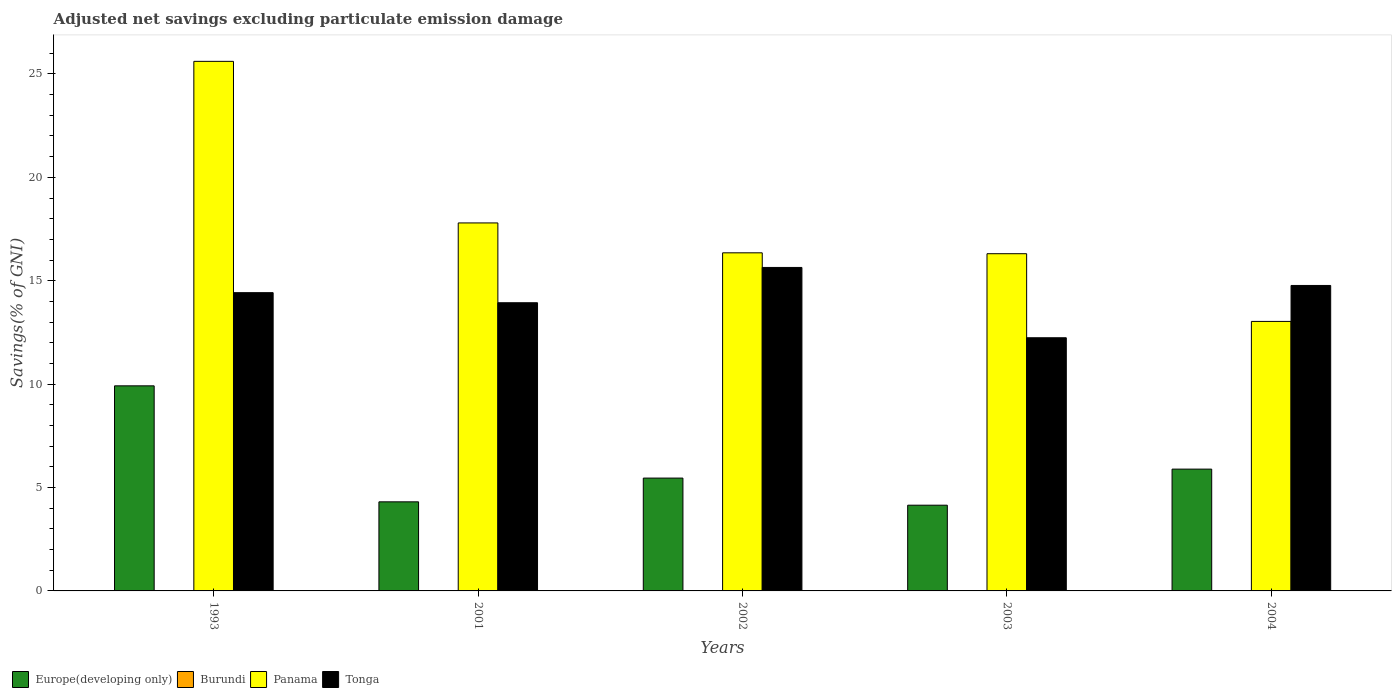How many different coloured bars are there?
Make the answer very short. 3. How many groups of bars are there?
Provide a short and direct response. 5. Are the number of bars on each tick of the X-axis equal?
Your answer should be very brief. Yes. How many bars are there on the 1st tick from the left?
Your response must be concise. 3. What is the label of the 4th group of bars from the left?
Make the answer very short. 2003. What is the adjusted net savings in Burundi in 2004?
Your answer should be compact. 0. Across all years, what is the maximum adjusted net savings in Panama?
Provide a short and direct response. 25.61. Across all years, what is the minimum adjusted net savings in Panama?
Your answer should be compact. 13.03. What is the total adjusted net savings in Europe(developing only) in the graph?
Your answer should be compact. 29.72. What is the difference between the adjusted net savings in Panama in 2001 and that in 2004?
Your response must be concise. 4.76. What is the difference between the adjusted net savings in Europe(developing only) in 1993 and the adjusted net savings in Panama in 2004?
Keep it short and to the point. -3.12. What is the average adjusted net savings in Burundi per year?
Offer a terse response. 0. In the year 1993, what is the difference between the adjusted net savings in Panama and adjusted net savings in Europe(developing only)?
Make the answer very short. 15.69. In how many years, is the adjusted net savings in Europe(developing only) greater than 20 %?
Your answer should be compact. 0. What is the ratio of the adjusted net savings in Panama in 2001 to that in 2004?
Provide a short and direct response. 1.37. What is the difference between the highest and the second highest adjusted net savings in Europe(developing only)?
Your answer should be compact. 4.03. What is the difference between the highest and the lowest adjusted net savings in Panama?
Give a very brief answer. 12.58. Is the sum of the adjusted net savings in Tonga in 1993 and 2003 greater than the maximum adjusted net savings in Panama across all years?
Ensure brevity in your answer.  Yes. Is it the case that in every year, the sum of the adjusted net savings in Burundi and adjusted net savings in Tonga is greater than the sum of adjusted net savings in Panama and adjusted net savings in Europe(developing only)?
Ensure brevity in your answer.  No. Is it the case that in every year, the sum of the adjusted net savings in Tonga and adjusted net savings in Burundi is greater than the adjusted net savings in Panama?
Ensure brevity in your answer.  No. How many bars are there?
Give a very brief answer. 15. How many years are there in the graph?
Provide a succinct answer. 5. What is the difference between two consecutive major ticks on the Y-axis?
Provide a succinct answer. 5. Are the values on the major ticks of Y-axis written in scientific E-notation?
Provide a succinct answer. No. Where does the legend appear in the graph?
Your answer should be very brief. Bottom left. How are the legend labels stacked?
Offer a very short reply. Horizontal. What is the title of the graph?
Ensure brevity in your answer.  Adjusted net savings excluding particulate emission damage. Does "Mauritania" appear as one of the legend labels in the graph?
Offer a terse response. No. What is the label or title of the Y-axis?
Provide a succinct answer. Savings(% of GNI). What is the Savings(% of GNI) of Europe(developing only) in 1993?
Offer a very short reply. 9.92. What is the Savings(% of GNI) in Burundi in 1993?
Your response must be concise. 0. What is the Savings(% of GNI) of Panama in 1993?
Provide a succinct answer. 25.61. What is the Savings(% of GNI) of Tonga in 1993?
Keep it short and to the point. 14.42. What is the Savings(% of GNI) of Europe(developing only) in 2001?
Offer a very short reply. 4.31. What is the Savings(% of GNI) in Panama in 2001?
Your answer should be compact. 17.8. What is the Savings(% of GNI) in Tonga in 2001?
Your response must be concise. 13.94. What is the Savings(% of GNI) of Europe(developing only) in 2002?
Give a very brief answer. 5.46. What is the Savings(% of GNI) of Burundi in 2002?
Provide a succinct answer. 0. What is the Savings(% of GNI) in Panama in 2002?
Offer a very short reply. 16.35. What is the Savings(% of GNI) of Tonga in 2002?
Provide a succinct answer. 15.64. What is the Savings(% of GNI) of Europe(developing only) in 2003?
Make the answer very short. 4.15. What is the Savings(% of GNI) of Burundi in 2003?
Your answer should be very brief. 0. What is the Savings(% of GNI) of Panama in 2003?
Provide a succinct answer. 16.31. What is the Savings(% of GNI) in Tonga in 2003?
Offer a terse response. 12.24. What is the Savings(% of GNI) in Europe(developing only) in 2004?
Offer a terse response. 5.89. What is the Savings(% of GNI) of Panama in 2004?
Keep it short and to the point. 13.03. What is the Savings(% of GNI) in Tonga in 2004?
Your answer should be compact. 14.77. Across all years, what is the maximum Savings(% of GNI) in Europe(developing only)?
Your answer should be very brief. 9.92. Across all years, what is the maximum Savings(% of GNI) in Panama?
Make the answer very short. 25.61. Across all years, what is the maximum Savings(% of GNI) in Tonga?
Give a very brief answer. 15.64. Across all years, what is the minimum Savings(% of GNI) in Europe(developing only)?
Give a very brief answer. 4.15. Across all years, what is the minimum Savings(% of GNI) of Panama?
Provide a succinct answer. 13.03. Across all years, what is the minimum Savings(% of GNI) of Tonga?
Give a very brief answer. 12.24. What is the total Savings(% of GNI) in Europe(developing only) in the graph?
Your answer should be very brief. 29.72. What is the total Savings(% of GNI) of Burundi in the graph?
Your response must be concise. 0. What is the total Savings(% of GNI) of Panama in the graph?
Your answer should be compact. 89.1. What is the total Savings(% of GNI) of Tonga in the graph?
Your response must be concise. 71.02. What is the difference between the Savings(% of GNI) in Europe(developing only) in 1993 and that in 2001?
Your response must be concise. 5.61. What is the difference between the Savings(% of GNI) in Panama in 1993 and that in 2001?
Make the answer very short. 7.81. What is the difference between the Savings(% of GNI) in Tonga in 1993 and that in 2001?
Your answer should be very brief. 0.49. What is the difference between the Savings(% of GNI) of Europe(developing only) in 1993 and that in 2002?
Provide a succinct answer. 4.46. What is the difference between the Savings(% of GNI) in Panama in 1993 and that in 2002?
Offer a very short reply. 9.26. What is the difference between the Savings(% of GNI) of Tonga in 1993 and that in 2002?
Ensure brevity in your answer.  -1.22. What is the difference between the Savings(% of GNI) in Europe(developing only) in 1993 and that in 2003?
Provide a short and direct response. 5.77. What is the difference between the Savings(% of GNI) of Panama in 1993 and that in 2003?
Keep it short and to the point. 9.3. What is the difference between the Savings(% of GNI) in Tonga in 1993 and that in 2003?
Your answer should be compact. 2.18. What is the difference between the Savings(% of GNI) in Europe(developing only) in 1993 and that in 2004?
Your response must be concise. 4.03. What is the difference between the Savings(% of GNI) in Panama in 1993 and that in 2004?
Give a very brief answer. 12.58. What is the difference between the Savings(% of GNI) in Tonga in 1993 and that in 2004?
Keep it short and to the point. -0.35. What is the difference between the Savings(% of GNI) of Europe(developing only) in 2001 and that in 2002?
Give a very brief answer. -1.15. What is the difference between the Savings(% of GNI) in Panama in 2001 and that in 2002?
Your answer should be compact. 1.45. What is the difference between the Savings(% of GNI) in Tonga in 2001 and that in 2002?
Ensure brevity in your answer.  -1.71. What is the difference between the Savings(% of GNI) of Europe(developing only) in 2001 and that in 2003?
Provide a succinct answer. 0.16. What is the difference between the Savings(% of GNI) in Panama in 2001 and that in 2003?
Your answer should be compact. 1.49. What is the difference between the Savings(% of GNI) of Tonga in 2001 and that in 2003?
Provide a short and direct response. 1.69. What is the difference between the Savings(% of GNI) in Europe(developing only) in 2001 and that in 2004?
Keep it short and to the point. -1.58. What is the difference between the Savings(% of GNI) of Panama in 2001 and that in 2004?
Offer a very short reply. 4.76. What is the difference between the Savings(% of GNI) of Tonga in 2001 and that in 2004?
Your answer should be compact. -0.84. What is the difference between the Savings(% of GNI) of Europe(developing only) in 2002 and that in 2003?
Your answer should be compact. 1.31. What is the difference between the Savings(% of GNI) in Panama in 2002 and that in 2003?
Offer a terse response. 0.04. What is the difference between the Savings(% of GNI) in Tonga in 2002 and that in 2003?
Keep it short and to the point. 3.4. What is the difference between the Savings(% of GNI) of Europe(developing only) in 2002 and that in 2004?
Provide a short and direct response. -0.43. What is the difference between the Savings(% of GNI) of Panama in 2002 and that in 2004?
Provide a succinct answer. 3.32. What is the difference between the Savings(% of GNI) of Tonga in 2002 and that in 2004?
Offer a very short reply. 0.87. What is the difference between the Savings(% of GNI) of Europe(developing only) in 2003 and that in 2004?
Keep it short and to the point. -1.74. What is the difference between the Savings(% of GNI) of Panama in 2003 and that in 2004?
Offer a very short reply. 3.27. What is the difference between the Savings(% of GNI) in Tonga in 2003 and that in 2004?
Offer a terse response. -2.53. What is the difference between the Savings(% of GNI) in Europe(developing only) in 1993 and the Savings(% of GNI) in Panama in 2001?
Offer a terse response. -7.88. What is the difference between the Savings(% of GNI) in Europe(developing only) in 1993 and the Savings(% of GNI) in Tonga in 2001?
Your answer should be very brief. -4.02. What is the difference between the Savings(% of GNI) of Panama in 1993 and the Savings(% of GNI) of Tonga in 2001?
Your response must be concise. 11.67. What is the difference between the Savings(% of GNI) in Europe(developing only) in 1993 and the Savings(% of GNI) in Panama in 2002?
Your response must be concise. -6.43. What is the difference between the Savings(% of GNI) in Europe(developing only) in 1993 and the Savings(% of GNI) in Tonga in 2002?
Offer a very short reply. -5.73. What is the difference between the Savings(% of GNI) of Panama in 1993 and the Savings(% of GNI) of Tonga in 2002?
Your response must be concise. 9.97. What is the difference between the Savings(% of GNI) in Europe(developing only) in 1993 and the Savings(% of GNI) in Panama in 2003?
Keep it short and to the point. -6.39. What is the difference between the Savings(% of GNI) in Europe(developing only) in 1993 and the Savings(% of GNI) in Tonga in 2003?
Give a very brief answer. -2.33. What is the difference between the Savings(% of GNI) of Panama in 1993 and the Savings(% of GNI) of Tonga in 2003?
Keep it short and to the point. 13.37. What is the difference between the Savings(% of GNI) in Europe(developing only) in 1993 and the Savings(% of GNI) in Panama in 2004?
Your answer should be compact. -3.12. What is the difference between the Savings(% of GNI) in Europe(developing only) in 1993 and the Savings(% of GNI) in Tonga in 2004?
Make the answer very short. -4.85. What is the difference between the Savings(% of GNI) of Panama in 1993 and the Savings(% of GNI) of Tonga in 2004?
Your answer should be very brief. 10.84. What is the difference between the Savings(% of GNI) in Europe(developing only) in 2001 and the Savings(% of GNI) in Panama in 2002?
Offer a very short reply. -12.04. What is the difference between the Savings(% of GNI) in Europe(developing only) in 2001 and the Savings(% of GNI) in Tonga in 2002?
Provide a succinct answer. -11.34. What is the difference between the Savings(% of GNI) in Panama in 2001 and the Savings(% of GNI) in Tonga in 2002?
Your answer should be compact. 2.15. What is the difference between the Savings(% of GNI) in Europe(developing only) in 2001 and the Savings(% of GNI) in Panama in 2003?
Give a very brief answer. -12. What is the difference between the Savings(% of GNI) in Europe(developing only) in 2001 and the Savings(% of GNI) in Tonga in 2003?
Your answer should be very brief. -7.93. What is the difference between the Savings(% of GNI) of Panama in 2001 and the Savings(% of GNI) of Tonga in 2003?
Provide a short and direct response. 5.55. What is the difference between the Savings(% of GNI) in Europe(developing only) in 2001 and the Savings(% of GNI) in Panama in 2004?
Give a very brief answer. -8.72. What is the difference between the Savings(% of GNI) in Europe(developing only) in 2001 and the Savings(% of GNI) in Tonga in 2004?
Ensure brevity in your answer.  -10.46. What is the difference between the Savings(% of GNI) of Panama in 2001 and the Savings(% of GNI) of Tonga in 2004?
Your answer should be very brief. 3.02. What is the difference between the Savings(% of GNI) in Europe(developing only) in 2002 and the Savings(% of GNI) in Panama in 2003?
Offer a terse response. -10.85. What is the difference between the Savings(% of GNI) in Europe(developing only) in 2002 and the Savings(% of GNI) in Tonga in 2003?
Offer a terse response. -6.79. What is the difference between the Savings(% of GNI) of Panama in 2002 and the Savings(% of GNI) of Tonga in 2003?
Your answer should be very brief. 4.11. What is the difference between the Savings(% of GNI) in Europe(developing only) in 2002 and the Savings(% of GNI) in Panama in 2004?
Your response must be concise. -7.58. What is the difference between the Savings(% of GNI) in Europe(developing only) in 2002 and the Savings(% of GNI) in Tonga in 2004?
Ensure brevity in your answer.  -9.31. What is the difference between the Savings(% of GNI) in Panama in 2002 and the Savings(% of GNI) in Tonga in 2004?
Ensure brevity in your answer.  1.58. What is the difference between the Savings(% of GNI) of Europe(developing only) in 2003 and the Savings(% of GNI) of Panama in 2004?
Offer a very short reply. -8.89. What is the difference between the Savings(% of GNI) in Europe(developing only) in 2003 and the Savings(% of GNI) in Tonga in 2004?
Give a very brief answer. -10.63. What is the difference between the Savings(% of GNI) of Panama in 2003 and the Savings(% of GNI) of Tonga in 2004?
Make the answer very short. 1.54. What is the average Savings(% of GNI) of Europe(developing only) per year?
Make the answer very short. 5.94. What is the average Savings(% of GNI) in Burundi per year?
Offer a terse response. 0. What is the average Savings(% of GNI) of Panama per year?
Provide a short and direct response. 17.82. What is the average Savings(% of GNI) of Tonga per year?
Give a very brief answer. 14.2. In the year 1993, what is the difference between the Savings(% of GNI) in Europe(developing only) and Savings(% of GNI) in Panama?
Your response must be concise. -15.69. In the year 1993, what is the difference between the Savings(% of GNI) in Europe(developing only) and Savings(% of GNI) in Tonga?
Offer a very short reply. -4.51. In the year 1993, what is the difference between the Savings(% of GNI) of Panama and Savings(% of GNI) of Tonga?
Offer a terse response. 11.19. In the year 2001, what is the difference between the Savings(% of GNI) of Europe(developing only) and Savings(% of GNI) of Panama?
Provide a succinct answer. -13.49. In the year 2001, what is the difference between the Savings(% of GNI) of Europe(developing only) and Savings(% of GNI) of Tonga?
Your answer should be very brief. -9.63. In the year 2001, what is the difference between the Savings(% of GNI) of Panama and Savings(% of GNI) of Tonga?
Your response must be concise. 3.86. In the year 2002, what is the difference between the Savings(% of GNI) in Europe(developing only) and Savings(% of GNI) in Panama?
Keep it short and to the point. -10.89. In the year 2002, what is the difference between the Savings(% of GNI) in Europe(developing only) and Savings(% of GNI) in Tonga?
Your response must be concise. -10.19. In the year 2002, what is the difference between the Savings(% of GNI) in Panama and Savings(% of GNI) in Tonga?
Provide a succinct answer. 0.71. In the year 2003, what is the difference between the Savings(% of GNI) in Europe(developing only) and Savings(% of GNI) in Panama?
Your answer should be very brief. -12.16. In the year 2003, what is the difference between the Savings(% of GNI) of Europe(developing only) and Savings(% of GNI) of Tonga?
Your answer should be compact. -8.1. In the year 2003, what is the difference between the Savings(% of GNI) of Panama and Savings(% of GNI) of Tonga?
Your answer should be very brief. 4.06. In the year 2004, what is the difference between the Savings(% of GNI) of Europe(developing only) and Savings(% of GNI) of Panama?
Your answer should be very brief. -7.14. In the year 2004, what is the difference between the Savings(% of GNI) of Europe(developing only) and Savings(% of GNI) of Tonga?
Keep it short and to the point. -8.88. In the year 2004, what is the difference between the Savings(% of GNI) of Panama and Savings(% of GNI) of Tonga?
Keep it short and to the point. -1.74. What is the ratio of the Savings(% of GNI) of Europe(developing only) in 1993 to that in 2001?
Your answer should be compact. 2.3. What is the ratio of the Savings(% of GNI) in Panama in 1993 to that in 2001?
Ensure brevity in your answer.  1.44. What is the ratio of the Savings(% of GNI) in Tonga in 1993 to that in 2001?
Keep it short and to the point. 1.03. What is the ratio of the Savings(% of GNI) of Europe(developing only) in 1993 to that in 2002?
Keep it short and to the point. 1.82. What is the ratio of the Savings(% of GNI) in Panama in 1993 to that in 2002?
Your response must be concise. 1.57. What is the ratio of the Savings(% of GNI) of Tonga in 1993 to that in 2002?
Ensure brevity in your answer.  0.92. What is the ratio of the Savings(% of GNI) of Europe(developing only) in 1993 to that in 2003?
Keep it short and to the point. 2.39. What is the ratio of the Savings(% of GNI) of Panama in 1993 to that in 2003?
Offer a very short reply. 1.57. What is the ratio of the Savings(% of GNI) in Tonga in 1993 to that in 2003?
Offer a terse response. 1.18. What is the ratio of the Savings(% of GNI) of Europe(developing only) in 1993 to that in 2004?
Give a very brief answer. 1.68. What is the ratio of the Savings(% of GNI) in Panama in 1993 to that in 2004?
Give a very brief answer. 1.97. What is the ratio of the Savings(% of GNI) of Tonga in 1993 to that in 2004?
Your answer should be compact. 0.98. What is the ratio of the Savings(% of GNI) in Europe(developing only) in 2001 to that in 2002?
Provide a short and direct response. 0.79. What is the ratio of the Savings(% of GNI) in Panama in 2001 to that in 2002?
Keep it short and to the point. 1.09. What is the ratio of the Savings(% of GNI) of Tonga in 2001 to that in 2002?
Your answer should be very brief. 0.89. What is the ratio of the Savings(% of GNI) in Europe(developing only) in 2001 to that in 2003?
Offer a terse response. 1.04. What is the ratio of the Savings(% of GNI) of Panama in 2001 to that in 2003?
Give a very brief answer. 1.09. What is the ratio of the Savings(% of GNI) in Tonga in 2001 to that in 2003?
Make the answer very short. 1.14. What is the ratio of the Savings(% of GNI) in Europe(developing only) in 2001 to that in 2004?
Make the answer very short. 0.73. What is the ratio of the Savings(% of GNI) in Panama in 2001 to that in 2004?
Your answer should be compact. 1.37. What is the ratio of the Savings(% of GNI) in Tonga in 2001 to that in 2004?
Offer a very short reply. 0.94. What is the ratio of the Savings(% of GNI) of Europe(developing only) in 2002 to that in 2003?
Your answer should be very brief. 1.32. What is the ratio of the Savings(% of GNI) of Panama in 2002 to that in 2003?
Keep it short and to the point. 1. What is the ratio of the Savings(% of GNI) of Tonga in 2002 to that in 2003?
Keep it short and to the point. 1.28. What is the ratio of the Savings(% of GNI) in Europe(developing only) in 2002 to that in 2004?
Your answer should be compact. 0.93. What is the ratio of the Savings(% of GNI) in Panama in 2002 to that in 2004?
Your answer should be very brief. 1.25. What is the ratio of the Savings(% of GNI) of Tonga in 2002 to that in 2004?
Your answer should be very brief. 1.06. What is the ratio of the Savings(% of GNI) in Europe(developing only) in 2003 to that in 2004?
Provide a succinct answer. 0.7. What is the ratio of the Savings(% of GNI) in Panama in 2003 to that in 2004?
Your answer should be compact. 1.25. What is the ratio of the Savings(% of GNI) of Tonga in 2003 to that in 2004?
Your response must be concise. 0.83. What is the difference between the highest and the second highest Savings(% of GNI) in Europe(developing only)?
Your answer should be compact. 4.03. What is the difference between the highest and the second highest Savings(% of GNI) in Panama?
Keep it short and to the point. 7.81. What is the difference between the highest and the second highest Savings(% of GNI) of Tonga?
Your response must be concise. 0.87. What is the difference between the highest and the lowest Savings(% of GNI) of Europe(developing only)?
Keep it short and to the point. 5.77. What is the difference between the highest and the lowest Savings(% of GNI) of Panama?
Keep it short and to the point. 12.58. What is the difference between the highest and the lowest Savings(% of GNI) in Tonga?
Your response must be concise. 3.4. 